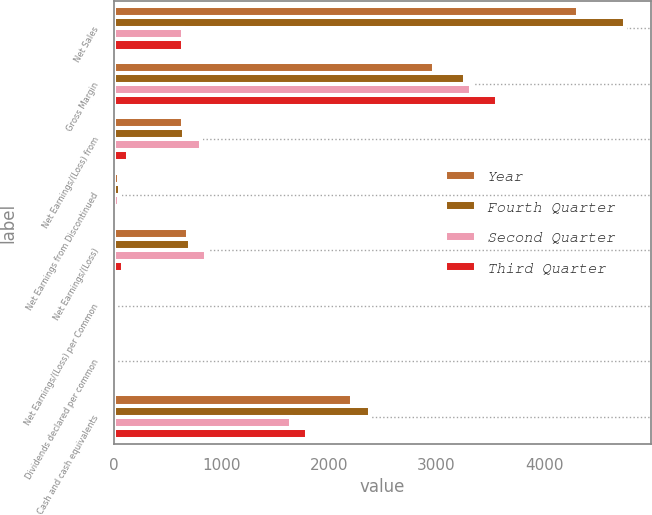Convert chart. <chart><loc_0><loc_0><loc_500><loc_500><stacked_bar_chart><ecel><fcel>Net Sales<fcel>Gross Margin<fcel>Net Earnings/(Loss) from<fcel>Net Earnings from Discontinued<fcel>Net Earnings/(Loss)<fcel>Net Earnings/(Loss) per Common<fcel>Dividends declared per common<fcel>Cash and cash equivalents<nl><fcel>Year<fcel>4317<fcel>2977<fcel>643<fcel>47<fcel>690<fcel>0.35<fcel>0.28<fcel>2214<nl><fcel>Fourth Quarter<fcel>4757<fcel>3265<fcel>650<fcel>56<fcel>706<fcel>0.36<fcel>0.28<fcel>2379<nl><fcel>Second Quarter<fcel>646.5<fcel>3324<fcel>808<fcel>50<fcel>858<fcel>0.43<fcel>0.28<fcel>1647<nl><fcel>Third Quarter<fcel>646.5<fcel>3564<fcel>133<fcel>44<fcel>89<fcel>0.05<fcel>0.31<fcel>1801<nl></chart> 